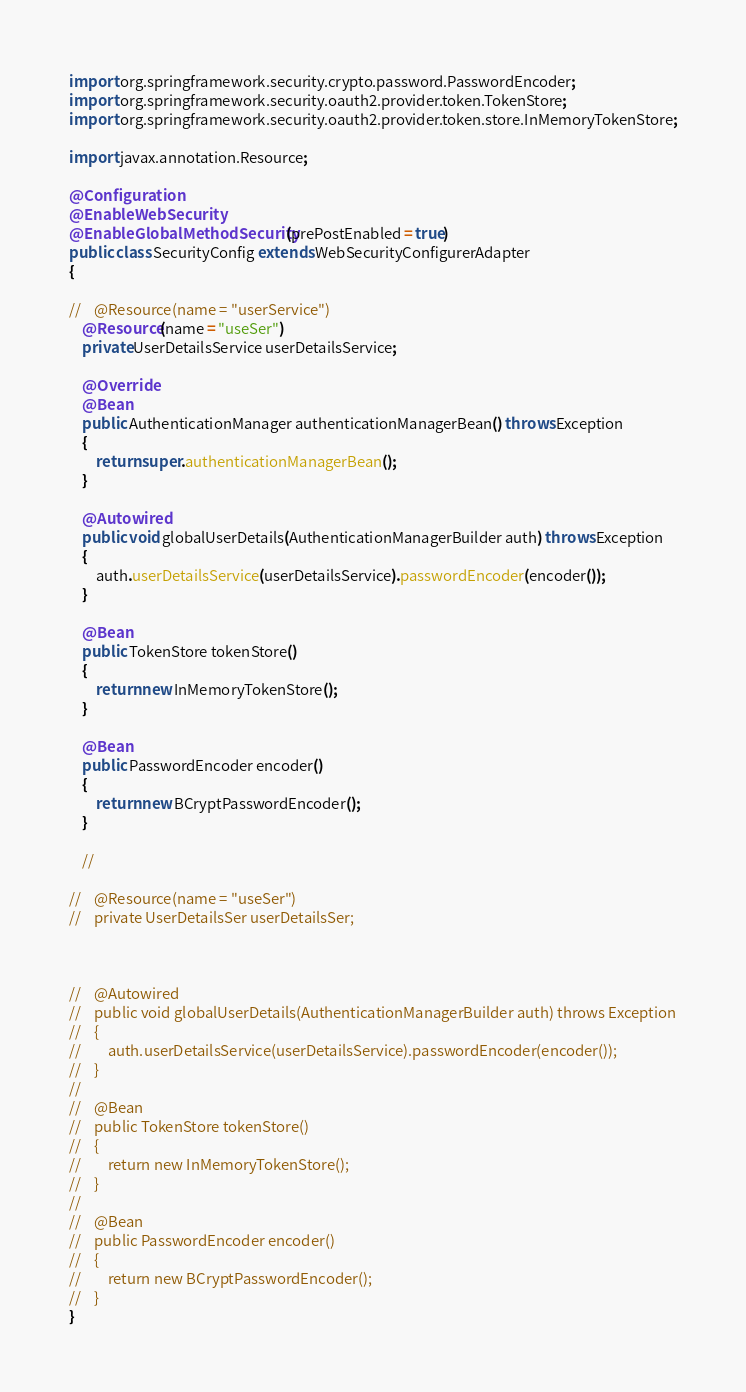Convert code to text. <code><loc_0><loc_0><loc_500><loc_500><_Java_>import org.springframework.security.crypto.password.PasswordEncoder;
import org.springframework.security.oauth2.provider.token.TokenStore;
import org.springframework.security.oauth2.provider.token.store.InMemoryTokenStore;

import javax.annotation.Resource;

@Configuration
@EnableWebSecurity
@EnableGlobalMethodSecurity(prePostEnabled = true)
public class SecurityConfig extends WebSecurityConfigurerAdapter
{

//    @Resource(name = "userService")
    @Resource(name = "useSer")
    private UserDetailsService userDetailsService;

    @Override
    @Bean
    public AuthenticationManager authenticationManagerBean() throws Exception
    {
        return super.authenticationManagerBean();
    }

    @Autowired
    public void globalUserDetails(AuthenticationManagerBuilder auth) throws Exception
    {
        auth.userDetailsService(userDetailsService).passwordEncoder(encoder());
    }

    @Bean
    public TokenStore tokenStore()
    {
        return new InMemoryTokenStore();
    }

    @Bean
    public PasswordEncoder encoder()
    {
        return new BCryptPasswordEncoder();
    }

    //

//    @Resource(name = "useSer")
//    private UserDetailsSer userDetailsSer;



//    @Autowired
//    public void globalUserDetails(AuthenticationManagerBuilder auth) throws Exception
//    {
//        auth.userDetailsService(userDetailsService).passwordEncoder(encoder());
//    }
//
//    @Bean
//    public TokenStore tokenStore()
//    {
//        return new InMemoryTokenStore();
//    }
//
//    @Bean
//    public PasswordEncoder encoder()
//    {
//        return new BCryptPasswordEncoder();
//    }
}</code> 